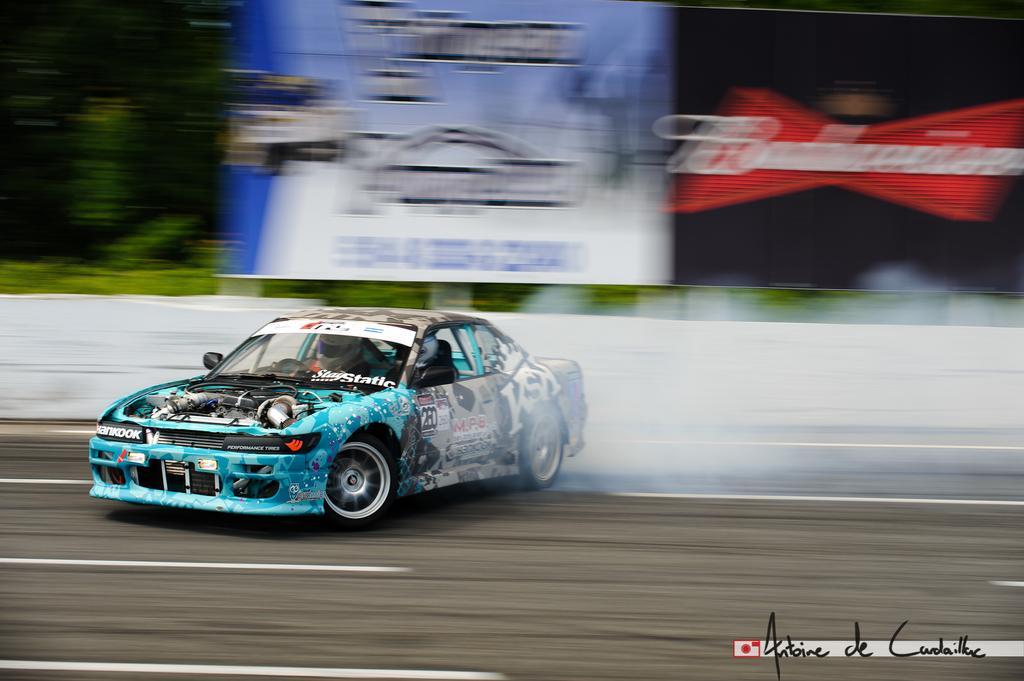How would you summarize this image in a sentence or two? This is the picture of a road. In this image there is a person riding a car on the road. At the back there are hoardings and there are trees. At the bottom there is a road. 